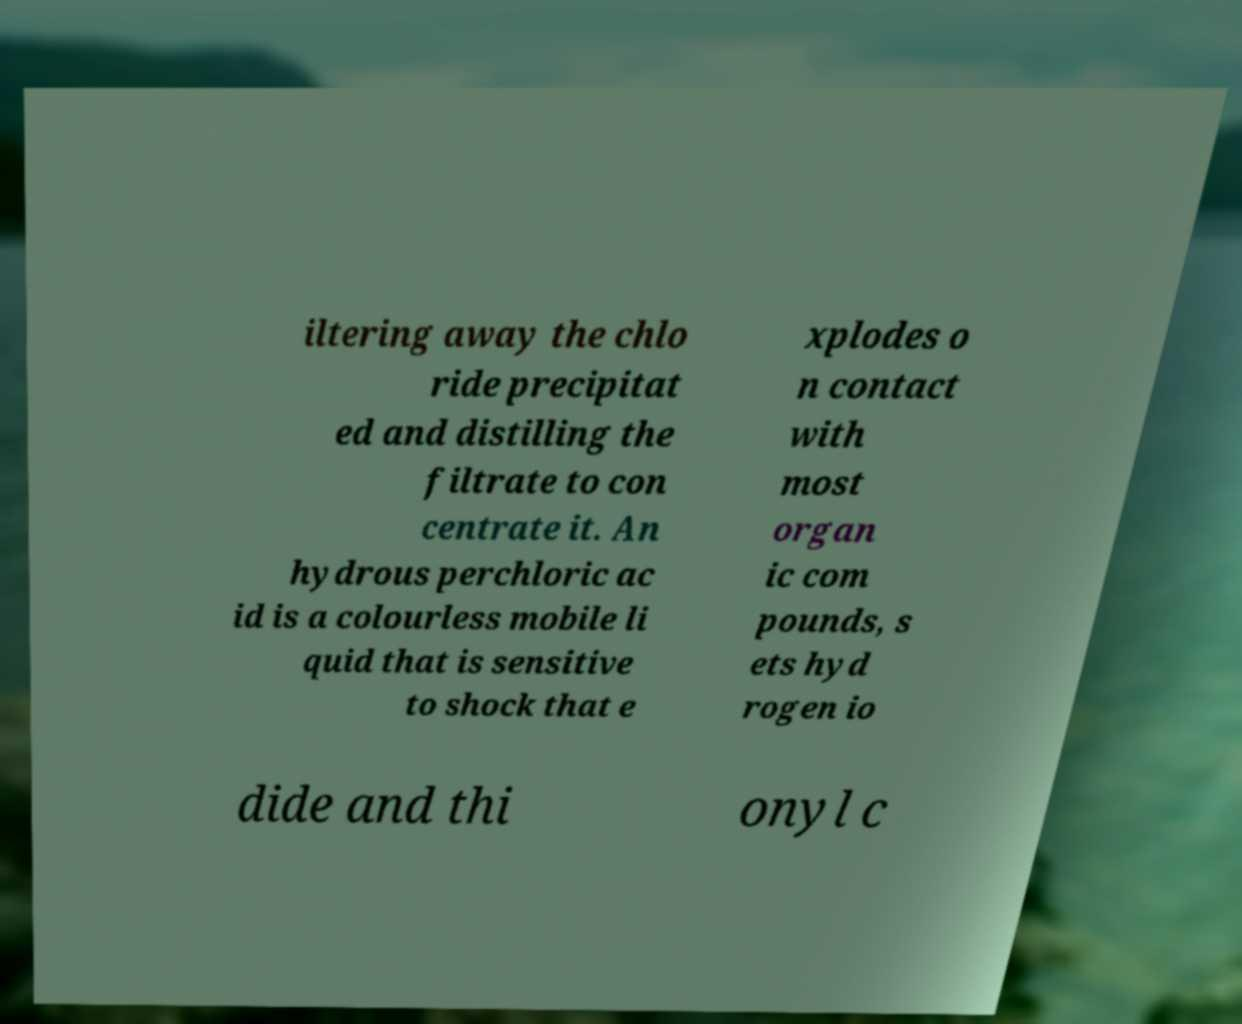For documentation purposes, I need the text within this image transcribed. Could you provide that? iltering away the chlo ride precipitat ed and distilling the filtrate to con centrate it. An hydrous perchloric ac id is a colourless mobile li quid that is sensitive to shock that e xplodes o n contact with most organ ic com pounds, s ets hyd rogen io dide and thi onyl c 